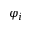Convert formula to latex. <formula><loc_0><loc_0><loc_500><loc_500>\varphi _ { i }</formula> 